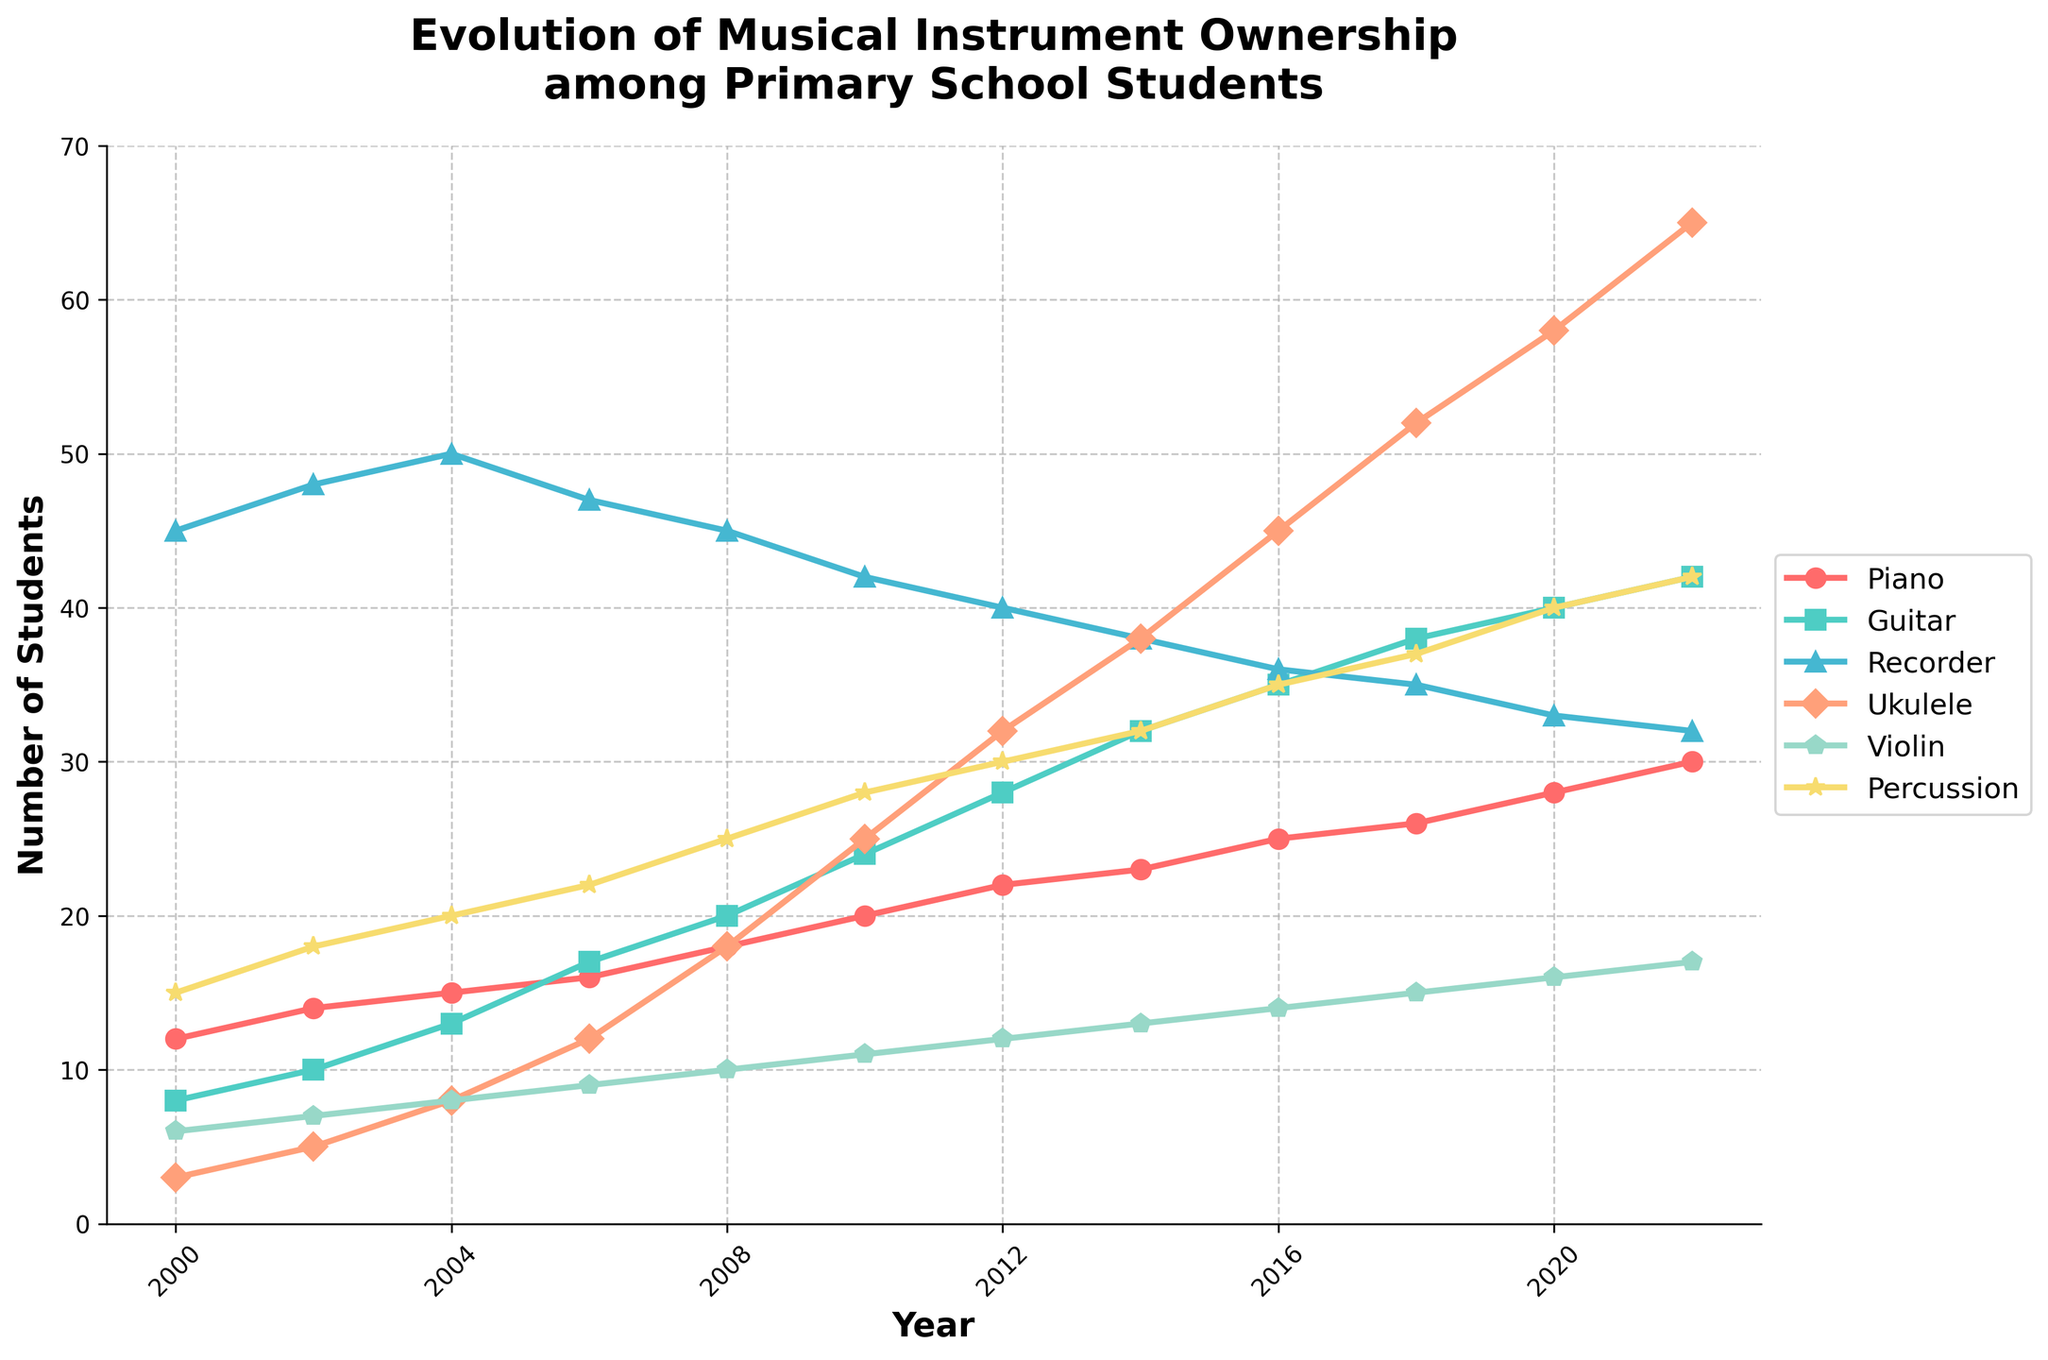Which instrument showed the highest increase in ownership from 2000 to 2022? To determine this, we need to find the difference in ownership numbers for each instrument between 2000 and 2022, then identify the highest value. For Piano, it's 30-12=18; for Guitar, it's 42-8=34; for Recorder, it's 32-45=-13; for Ukulele, it's 65-3=62; for Violin, it's 17-6=11; for Percussion, it's 42-15=27. Therefore, the highest increase is for Ukulele (62).
Answer: Ukulele Which instrument had the lowest ownership in 2022? Refer to the data points for 2022 and identify the smallest value among the instruments. In 2022, the values are: Piano 30, Guitar 42, Recorder 32, Ukulele 65, Violin 17, Percussion 42. The lowest ownership is for Violin, with a value of 17.
Answer: Violin How did the ownership of the Recorder change from 2000 to 2022? Look at the data points for Recorder in 2000 and 2022. In 2000, it was 45, and in 2022, it was 32. The change is given by 32 - 45 = -13, meaning there was a decrease in ownership by 13 students.
Answer: Decreased by 13 In which year did the number of students owning the Violin surpass 10? Check the yearly data for Violin and find the first year where the value exceeds 10. The values are: 2000:6, 2002:7, 2004:8, 2006:9, 2008:10, 2010:11. The Violin ownership surpasses 10 in 2010.
Answer: 2010 What is the average number of students owning Guitars from 2000 to 2022? To find the average, sum all the Guitar ownership numbers from 2000 to 2022 and divide by the number of years. Sum = 8+10+13+17+20+24+28+32+35+38+40+42 = 307. Number of years = 12. So, the average is 307/12 ≈ 25.58.
Answer: ~25.58 Which two instruments have the same ownership in 2022? Compare the data for all instruments in 2022. Piano had 30, Guitar 42, Recorder 32, Ukulele 65, Violin 17, and Percussion 42. Guitar and Percussion have the same ownership, 42.
Answer: Guitar and Percussion How many more students owned Ukuleles in 2022 compared to 2010? Subtract the 2010 Ukulele ownership from the 2022 ownership: 65 - 25 = 40. Thus, there are 40 more students owning Ukuleles in 2022 compared to 2010.
Answer: 40 Which year shows the highest ownership for any single instrument? What is the instrument? Examine the peak values for each instrument and note the years. The highest point is for Ukulele in 2022 with 65 students.
Answer: 2022, Ukulele Between 2000 and 2022, which instrument's ownership consistently increased every recorded year? Check each instrument's data over the years to verify consistent increase. Only the ownership of Ukulele shows consistent yearly increase within the time frame.
Answer: Ukulele By how much did Percussion ownership change from 2008 to 2014? Subtract the 2008 value from the 2014 value for Percussion: 32 - 25 = 7. Thus, there was an increase of 7 students.
Answer: Increased by 7 